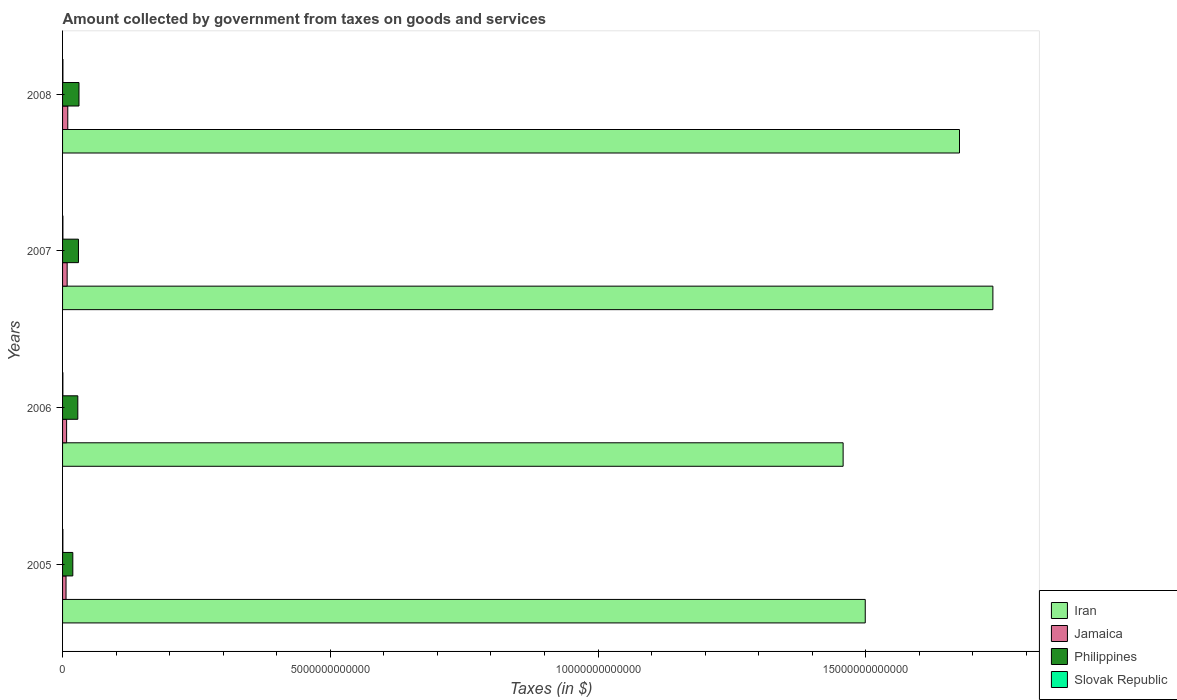How many different coloured bars are there?
Keep it short and to the point. 4. How many bars are there on the 1st tick from the top?
Offer a very short reply. 4. How many bars are there on the 3rd tick from the bottom?
Give a very brief answer. 4. In how many cases, is the number of bars for a given year not equal to the number of legend labels?
Provide a short and direct response. 0. What is the amount collected by government from taxes on goods and services in Slovak Republic in 2008?
Provide a succinct answer. 6.57e+09. Across all years, what is the maximum amount collected by government from taxes on goods and services in Philippines?
Make the answer very short. 3.07e+11. Across all years, what is the minimum amount collected by government from taxes on goods and services in Slovak Republic?
Offer a terse response. 5.78e+09. In which year was the amount collected by government from taxes on goods and services in Jamaica minimum?
Offer a very short reply. 2005. What is the total amount collected by government from taxes on goods and services in Philippines in the graph?
Offer a terse response. 1.08e+12. What is the difference between the amount collected by government from taxes on goods and services in Iran in 2005 and that in 2007?
Offer a very short reply. -2.38e+12. What is the difference between the amount collected by government from taxes on goods and services in Philippines in 2008 and the amount collected by government from taxes on goods and services in Jamaica in 2007?
Provide a succinct answer. 2.21e+11. What is the average amount collected by government from taxes on goods and services in Iran per year?
Offer a terse response. 1.59e+13. In the year 2006, what is the difference between the amount collected by government from taxes on goods and services in Slovak Republic and amount collected by government from taxes on goods and services in Iran?
Your response must be concise. -1.46e+13. What is the ratio of the amount collected by government from taxes on goods and services in Philippines in 2006 to that in 2007?
Give a very brief answer. 0.96. Is the difference between the amount collected by government from taxes on goods and services in Slovak Republic in 2005 and 2008 greater than the difference between the amount collected by government from taxes on goods and services in Iran in 2005 and 2008?
Offer a very short reply. Yes. What is the difference between the highest and the second highest amount collected by government from taxes on goods and services in Philippines?
Ensure brevity in your answer.  1.01e+1. What is the difference between the highest and the lowest amount collected by government from taxes on goods and services in Slovak Republic?
Provide a succinct answer. 7.99e+08. Is the sum of the amount collected by government from taxes on goods and services in Jamaica in 2005 and 2006 greater than the maximum amount collected by government from taxes on goods and services in Slovak Republic across all years?
Make the answer very short. Yes. What does the 1st bar from the top in 2007 represents?
Provide a short and direct response. Slovak Republic. How many bars are there?
Your answer should be very brief. 16. What is the difference between two consecutive major ticks on the X-axis?
Offer a terse response. 5.00e+12. Are the values on the major ticks of X-axis written in scientific E-notation?
Your answer should be very brief. No. Does the graph contain grids?
Provide a short and direct response. No. What is the title of the graph?
Your answer should be very brief. Amount collected by government from taxes on goods and services. What is the label or title of the X-axis?
Offer a very short reply. Taxes (in $). What is the label or title of the Y-axis?
Ensure brevity in your answer.  Years. What is the Taxes (in $) of Iran in 2005?
Offer a very short reply. 1.50e+13. What is the Taxes (in $) in Jamaica in 2005?
Keep it short and to the point. 6.48e+1. What is the Taxes (in $) of Philippines in 2005?
Give a very brief answer. 1.91e+11. What is the Taxes (in $) of Slovak Republic in 2005?
Provide a short and direct response. 5.78e+09. What is the Taxes (in $) of Iran in 2006?
Make the answer very short. 1.46e+13. What is the Taxes (in $) in Jamaica in 2006?
Ensure brevity in your answer.  7.54e+1. What is the Taxes (in $) of Philippines in 2006?
Give a very brief answer. 2.85e+11. What is the Taxes (in $) of Slovak Republic in 2006?
Offer a terse response. 5.88e+09. What is the Taxes (in $) of Iran in 2007?
Provide a short and direct response. 1.74e+13. What is the Taxes (in $) in Jamaica in 2007?
Provide a succinct answer. 8.58e+1. What is the Taxes (in $) in Philippines in 2007?
Ensure brevity in your answer.  2.97e+11. What is the Taxes (in $) in Slovak Republic in 2007?
Provide a short and direct response. 6.47e+09. What is the Taxes (in $) of Iran in 2008?
Make the answer very short. 1.68e+13. What is the Taxes (in $) of Jamaica in 2008?
Provide a succinct answer. 9.74e+1. What is the Taxes (in $) of Philippines in 2008?
Keep it short and to the point. 3.07e+11. What is the Taxes (in $) in Slovak Republic in 2008?
Your answer should be compact. 6.57e+09. Across all years, what is the maximum Taxes (in $) of Iran?
Offer a terse response. 1.74e+13. Across all years, what is the maximum Taxes (in $) of Jamaica?
Offer a terse response. 9.74e+1. Across all years, what is the maximum Taxes (in $) in Philippines?
Give a very brief answer. 3.07e+11. Across all years, what is the maximum Taxes (in $) in Slovak Republic?
Provide a succinct answer. 6.57e+09. Across all years, what is the minimum Taxes (in $) of Iran?
Make the answer very short. 1.46e+13. Across all years, what is the minimum Taxes (in $) in Jamaica?
Provide a succinct answer. 6.48e+1. Across all years, what is the minimum Taxes (in $) of Philippines?
Provide a succinct answer. 1.91e+11. Across all years, what is the minimum Taxes (in $) of Slovak Republic?
Provide a succinct answer. 5.78e+09. What is the total Taxes (in $) in Iran in the graph?
Ensure brevity in your answer.  6.37e+13. What is the total Taxes (in $) of Jamaica in the graph?
Make the answer very short. 3.23e+11. What is the total Taxes (in $) in Philippines in the graph?
Your answer should be very brief. 1.08e+12. What is the total Taxes (in $) in Slovak Republic in the graph?
Your answer should be compact. 2.47e+1. What is the difference between the Taxes (in $) of Iran in 2005 and that in 2006?
Offer a terse response. 4.13e+11. What is the difference between the Taxes (in $) of Jamaica in 2005 and that in 2006?
Provide a succinct answer. -1.07e+1. What is the difference between the Taxes (in $) of Philippines in 2005 and that in 2006?
Your answer should be compact. -9.34e+1. What is the difference between the Taxes (in $) of Slovak Republic in 2005 and that in 2006?
Keep it short and to the point. -1.08e+08. What is the difference between the Taxes (in $) in Iran in 2005 and that in 2007?
Provide a succinct answer. -2.38e+12. What is the difference between the Taxes (in $) in Jamaica in 2005 and that in 2007?
Your answer should be very brief. -2.10e+1. What is the difference between the Taxes (in $) of Philippines in 2005 and that in 2007?
Provide a succinct answer. -1.05e+11. What is the difference between the Taxes (in $) in Slovak Republic in 2005 and that in 2007?
Make the answer very short. -6.91e+08. What is the difference between the Taxes (in $) of Iran in 2005 and that in 2008?
Your answer should be very brief. -1.76e+12. What is the difference between the Taxes (in $) of Jamaica in 2005 and that in 2008?
Give a very brief answer. -3.27e+1. What is the difference between the Taxes (in $) in Philippines in 2005 and that in 2008?
Provide a succinct answer. -1.15e+11. What is the difference between the Taxes (in $) in Slovak Republic in 2005 and that in 2008?
Give a very brief answer. -7.99e+08. What is the difference between the Taxes (in $) in Iran in 2006 and that in 2007?
Make the answer very short. -2.80e+12. What is the difference between the Taxes (in $) of Jamaica in 2006 and that in 2007?
Provide a short and direct response. -1.03e+1. What is the difference between the Taxes (in $) of Philippines in 2006 and that in 2007?
Give a very brief answer. -1.19e+1. What is the difference between the Taxes (in $) in Slovak Republic in 2006 and that in 2007?
Your response must be concise. -5.83e+08. What is the difference between the Taxes (in $) in Iran in 2006 and that in 2008?
Your response must be concise. -2.17e+12. What is the difference between the Taxes (in $) in Jamaica in 2006 and that in 2008?
Your answer should be very brief. -2.20e+1. What is the difference between the Taxes (in $) in Philippines in 2006 and that in 2008?
Make the answer very short. -2.20e+1. What is the difference between the Taxes (in $) of Slovak Republic in 2006 and that in 2008?
Your response must be concise. -6.91e+08. What is the difference between the Taxes (in $) in Iran in 2007 and that in 2008?
Provide a succinct answer. 6.24e+11. What is the difference between the Taxes (in $) of Jamaica in 2007 and that in 2008?
Make the answer very short. -1.16e+1. What is the difference between the Taxes (in $) in Philippines in 2007 and that in 2008?
Make the answer very short. -1.01e+1. What is the difference between the Taxes (in $) of Slovak Republic in 2007 and that in 2008?
Keep it short and to the point. -1.08e+08. What is the difference between the Taxes (in $) of Iran in 2005 and the Taxes (in $) of Jamaica in 2006?
Your response must be concise. 1.49e+13. What is the difference between the Taxes (in $) of Iran in 2005 and the Taxes (in $) of Philippines in 2006?
Provide a succinct answer. 1.47e+13. What is the difference between the Taxes (in $) in Iran in 2005 and the Taxes (in $) in Slovak Republic in 2006?
Give a very brief answer. 1.50e+13. What is the difference between the Taxes (in $) in Jamaica in 2005 and the Taxes (in $) in Philippines in 2006?
Keep it short and to the point. -2.20e+11. What is the difference between the Taxes (in $) of Jamaica in 2005 and the Taxes (in $) of Slovak Republic in 2006?
Your answer should be compact. 5.89e+1. What is the difference between the Taxes (in $) in Philippines in 2005 and the Taxes (in $) in Slovak Republic in 2006?
Your answer should be very brief. 1.85e+11. What is the difference between the Taxes (in $) of Iran in 2005 and the Taxes (in $) of Jamaica in 2007?
Provide a short and direct response. 1.49e+13. What is the difference between the Taxes (in $) in Iran in 2005 and the Taxes (in $) in Philippines in 2007?
Your answer should be compact. 1.47e+13. What is the difference between the Taxes (in $) of Iran in 2005 and the Taxes (in $) of Slovak Republic in 2007?
Make the answer very short. 1.50e+13. What is the difference between the Taxes (in $) in Jamaica in 2005 and the Taxes (in $) in Philippines in 2007?
Your response must be concise. -2.32e+11. What is the difference between the Taxes (in $) in Jamaica in 2005 and the Taxes (in $) in Slovak Republic in 2007?
Your answer should be very brief. 5.83e+1. What is the difference between the Taxes (in $) of Philippines in 2005 and the Taxes (in $) of Slovak Republic in 2007?
Offer a very short reply. 1.85e+11. What is the difference between the Taxes (in $) of Iran in 2005 and the Taxes (in $) of Jamaica in 2008?
Your answer should be compact. 1.49e+13. What is the difference between the Taxes (in $) of Iran in 2005 and the Taxes (in $) of Philippines in 2008?
Ensure brevity in your answer.  1.47e+13. What is the difference between the Taxes (in $) of Iran in 2005 and the Taxes (in $) of Slovak Republic in 2008?
Provide a short and direct response. 1.50e+13. What is the difference between the Taxes (in $) of Jamaica in 2005 and the Taxes (in $) of Philippines in 2008?
Your answer should be very brief. -2.42e+11. What is the difference between the Taxes (in $) of Jamaica in 2005 and the Taxes (in $) of Slovak Republic in 2008?
Provide a succinct answer. 5.82e+1. What is the difference between the Taxes (in $) in Philippines in 2005 and the Taxes (in $) in Slovak Republic in 2008?
Your answer should be compact. 1.85e+11. What is the difference between the Taxes (in $) in Iran in 2006 and the Taxes (in $) in Jamaica in 2007?
Offer a terse response. 1.45e+13. What is the difference between the Taxes (in $) in Iran in 2006 and the Taxes (in $) in Philippines in 2007?
Make the answer very short. 1.43e+13. What is the difference between the Taxes (in $) in Iran in 2006 and the Taxes (in $) in Slovak Republic in 2007?
Provide a short and direct response. 1.46e+13. What is the difference between the Taxes (in $) of Jamaica in 2006 and the Taxes (in $) of Philippines in 2007?
Your response must be concise. -2.21e+11. What is the difference between the Taxes (in $) of Jamaica in 2006 and the Taxes (in $) of Slovak Republic in 2007?
Give a very brief answer. 6.90e+1. What is the difference between the Taxes (in $) in Philippines in 2006 and the Taxes (in $) in Slovak Republic in 2007?
Give a very brief answer. 2.78e+11. What is the difference between the Taxes (in $) of Iran in 2006 and the Taxes (in $) of Jamaica in 2008?
Ensure brevity in your answer.  1.45e+13. What is the difference between the Taxes (in $) in Iran in 2006 and the Taxes (in $) in Philippines in 2008?
Your answer should be very brief. 1.43e+13. What is the difference between the Taxes (in $) in Iran in 2006 and the Taxes (in $) in Slovak Republic in 2008?
Keep it short and to the point. 1.46e+13. What is the difference between the Taxes (in $) in Jamaica in 2006 and the Taxes (in $) in Philippines in 2008?
Ensure brevity in your answer.  -2.31e+11. What is the difference between the Taxes (in $) of Jamaica in 2006 and the Taxes (in $) of Slovak Republic in 2008?
Provide a short and direct response. 6.89e+1. What is the difference between the Taxes (in $) of Philippines in 2006 and the Taxes (in $) of Slovak Republic in 2008?
Make the answer very short. 2.78e+11. What is the difference between the Taxes (in $) in Iran in 2007 and the Taxes (in $) in Jamaica in 2008?
Your answer should be compact. 1.73e+13. What is the difference between the Taxes (in $) of Iran in 2007 and the Taxes (in $) of Philippines in 2008?
Your answer should be compact. 1.71e+13. What is the difference between the Taxes (in $) in Iran in 2007 and the Taxes (in $) in Slovak Republic in 2008?
Give a very brief answer. 1.74e+13. What is the difference between the Taxes (in $) of Jamaica in 2007 and the Taxes (in $) of Philippines in 2008?
Keep it short and to the point. -2.21e+11. What is the difference between the Taxes (in $) in Jamaica in 2007 and the Taxes (in $) in Slovak Republic in 2008?
Keep it short and to the point. 7.92e+1. What is the difference between the Taxes (in $) of Philippines in 2007 and the Taxes (in $) of Slovak Republic in 2008?
Ensure brevity in your answer.  2.90e+11. What is the average Taxes (in $) in Iran per year?
Keep it short and to the point. 1.59e+13. What is the average Taxes (in $) of Jamaica per year?
Make the answer very short. 8.08e+1. What is the average Taxes (in $) of Philippines per year?
Make the answer very short. 2.70e+11. What is the average Taxes (in $) of Slovak Republic per year?
Provide a short and direct response. 6.18e+09. In the year 2005, what is the difference between the Taxes (in $) of Iran and Taxes (in $) of Jamaica?
Offer a terse response. 1.49e+13. In the year 2005, what is the difference between the Taxes (in $) of Iran and Taxes (in $) of Philippines?
Provide a succinct answer. 1.48e+13. In the year 2005, what is the difference between the Taxes (in $) in Iran and Taxes (in $) in Slovak Republic?
Provide a short and direct response. 1.50e+13. In the year 2005, what is the difference between the Taxes (in $) in Jamaica and Taxes (in $) in Philippines?
Your answer should be very brief. -1.27e+11. In the year 2005, what is the difference between the Taxes (in $) of Jamaica and Taxes (in $) of Slovak Republic?
Keep it short and to the point. 5.90e+1. In the year 2005, what is the difference between the Taxes (in $) in Philippines and Taxes (in $) in Slovak Republic?
Offer a terse response. 1.86e+11. In the year 2006, what is the difference between the Taxes (in $) in Iran and Taxes (in $) in Jamaica?
Offer a terse response. 1.45e+13. In the year 2006, what is the difference between the Taxes (in $) in Iran and Taxes (in $) in Philippines?
Ensure brevity in your answer.  1.43e+13. In the year 2006, what is the difference between the Taxes (in $) in Iran and Taxes (in $) in Slovak Republic?
Ensure brevity in your answer.  1.46e+13. In the year 2006, what is the difference between the Taxes (in $) in Jamaica and Taxes (in $) in Philippines?
Offer a terse response. -2.09e+11. In the year 2006, what is the difference between the Taxes (in $) of Jamaica and Taxes (in $) of Slovak Republic?
Provide a succinct answer. 6.95e+1. In the year 2006, what is the difference between the Taxes (in $) of Philippines and Taxes (in $) of Slovak Republic?
Offer a terse response. 2.79e+11. In the year 2007, what is the difference between the Taxes (in $) of Iran and Taxes (in $) of Jamaica?
Ensure brevity in your answer.  1.73e+13. In the year 2007, what is the difference between the Taxes (in $) of Iran and Taxes (in $) of Philippines?
Ensure brevity in your answer.  1.71e+13. In the year 2007, what is the difference between the Taxes (in $) of Iran and Taxes (in $) of Slovak Republic?
Give a very brief answer. 1.74e+13. In the year 2007, what is the difference between the Taxes (in $) of Jamaica and Taxes (in $) of Philippines?
Offer a very short reply. -2.11e+11. In the year 2007, what is the difference between the Taxes (in $) of Jamaica and Taxes (in $) of Slovak Republic?
Ensure brevity in your answer.  7.93e+1. In the year 2007, what is the difference between the Taxes (in $) in Philippines and Taxes (in $) in Slovak Republic?
Your response must be concise. 2.90e+11. In the year 2008, what is the difference between the Taxes (in $) in Iran and Taxes (in $) in Jamaica?
Your answer should be very brief. 1.67e+13. In the year 2008, what is the difference between the Taxes (in $) in Iran and Taxes (in $) in Philippines?
Offer a very short reply. 1.64e+13. In the year 2008, what is the difference between the Taxes (in $) of Iran and Taxes (in $) of Slovak Republic?
Make the answer very short. 1.67e+13. In the year 2008, what is the difference between the Taxes (in $) in Jamaica and Taxes (in $) in Philippines?
Ensure brevity in your answer.  -2.09e+11. In the year 2008, what is the difference between the Taxes (in $) of Jamaica and Taxes (in $) of Slovak Republic?
Your response must be concise. 9.08e+1. In the year 2008, what is the difference between the Taxes (in $) in Philippines and Taxes (in $) in Slovak Republic?
Give a very brief answer. 3.00e+11. What is the ratio of the Taxes (in $) in Iran in 2005 to that in 2006?
Your answer should be very brief. 1.03. What is the ratio of the Taxes (in $) of Jamaica in 2005 to that in 2006?
Keep it short and to the point. 0.86. What is the ratio of the Taxes (in $) of Philippines in 2005 to that in 2006?
Provide a succinct answer. 0.67. What is the ratio of the Taxes (in $) of Slovak Republic in 2005 to that in 2006?
Your response must be concise. 0.98. What is the ratio of the Taxes (in $) of Iran in 2005 to that in 2007?
Offer a terse response. 0.86. What is the ratio of the Taxes (in $) of Jamaica in 2005 to that in 2007?
Provide a succinct answer. 0.76. What is the ratio of the Taxes (in $) in Philippines in 2005 to that in 2007?
Offer a very short reply. 0.65. What is the ratio of the Taxes (in $) in Slovak Republic in 2005 to that in 2007?
Offer a terse response. 0.89. What is the ratio of the Taxes (in $) in Iran in 2005 to that in 2008?
Your answer should be compact. 0.89. What is the ratio of the Taxes (in $) in Jamaica in 2005 to that in 2008?
Ensure brevity in your answer.  0.66. What is the ratio of the Taxes (in $) of Philippines in 2005 to that in 2008?
Give a very brief answer. 0.62. What is the ratio of the Taxes (in $) of Slovak Republic in 2005 to that in 2008?
Offer a terse response. 0.88. What is the ratio of the Taxes (in $) in Iran in 2006 to that in 2007?
Ensure brevity in your answer.  0.84. What is the ratio of the Taxes (in $) in Jamaica in 2006 to that in 2007?
Your answer should be very brief. 0.88. What is the ratio of the Taxes (in $) in Philippines in 2006 to that in 2007?
Your answer should be compact. 0.96. What is the ratio of the Taxes (in $) in Slovak Republic in 2006 to that in 2007?
Give a very brief answer. 0.91. What is the ratio of the Taxes (in $) in Iran in 2006 to that in 2008?
Your answer should be very brief. 0.87. What is the ratio of the Taxes (in $) of Jamaica in 2006 to that in 2008?
Provide a succinct answer. 0.77. What is the ratio of the Taxes (in $) in Philippines in 2006 to that in 2008?
Your answer should be very brief. 0.93. What is the ratio of the Taxes (in $) in Slovak Republic in 2006 to that in 2008?
Offer a terse response. 0.89. What is the ratio of the Taxes (in $) of Iran in 2007 to that in 2008?
Your answer should be very brief. 1.04. What is the ratio of the Taxes (in $) in Jamaica in 2007 to that in 2008?
Give a very brief answer. 0.88. What is the ratio of the Taxes (in $) of Philippines in 2007 to that in 2008?
Your answer should be compact. 0.97. What is the ratio of the Taxes (in $) in Slovak Republic in 2007 to that in 2008?
Your answer should be very brief. 0.98. What is the difference between the highest and the second highest Taxes (in $) in Iran?
Keep it short and to the point. 6.24e+11. What is the difference between the highest and the second highest Taxes (in $) in Jamaica?
Your answer should be very brief. 1.16e+1. What is the difference between the highest and the second highest Taxes (in $) of Philippines?
Give a very brief answer. 1.01e+1. What is the difference between the highest and the second highest Taxes (in $) in Slovak Republic?
Give a very brief answer. 1.08e+08. What is the difference between the highest and the lowest Taxes (in $) of Iran?
Your answer should be compact. 2.80e+12. What is the difference between the highest and the lowest Taxes (in $) in Jamaica?
Your answer should be compact. 3.27e+1. What is the difference between the highest and the lowest Taxes (in $) of Philippines?
Your answer should be compact. 1.15e+11. What is the difference between the highest and the lowest Taxes (in $) of Slovak Republic?
Provide a succinct answer. 7.99e+08. 